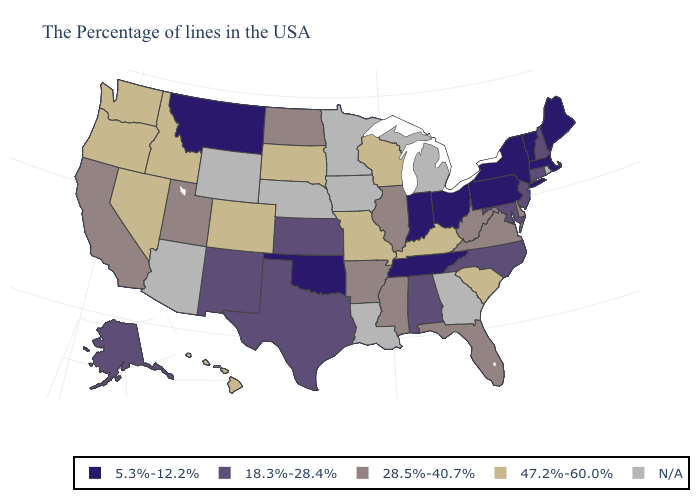Name the states that have a value in the range 47.2%-60.0%?
Concise answer only. South Carolina, Kentucky, Wisconsin, Missouri, South Dakota, Colorado, Idaho, Nevada, Washington, Oregon, Hawaii. What is the value of Pennsylvania?
Short answer required. 5.3%-12.2%. What is the highest value in the Northeast ?
Give a very brief answer. 18.3%-28.4%. Does the map have missing data?
Give a very brief answer. Yes. What is the highest value in states that border Nevada?
Concise answer only. 47.2%-60.0%. What is the lowest value in states that border New Hampshire?
Give a very brief answer. 5.3%-12.2%. What is the value of Virginia?
Concise answer only. 28.5%-40.7%. What is the highest value in the USA?
Be succinct. 47.2%-60.0%. Among the states that border North Carolina , which have the lowest value?
Short answer required. Tennessee. Name the states that have a value in the range N/A?
Short answer required. Rhode Island, Georgia, Michigan, Louisiana, Minnesota, Iowa, Nebraska, Wyoming, Arizona. Does the first symbol in the legend represent the smallest category?
Short answer required. Yes. Does Nevada have the highest value in the USA?
Concise answer only. Yes. 